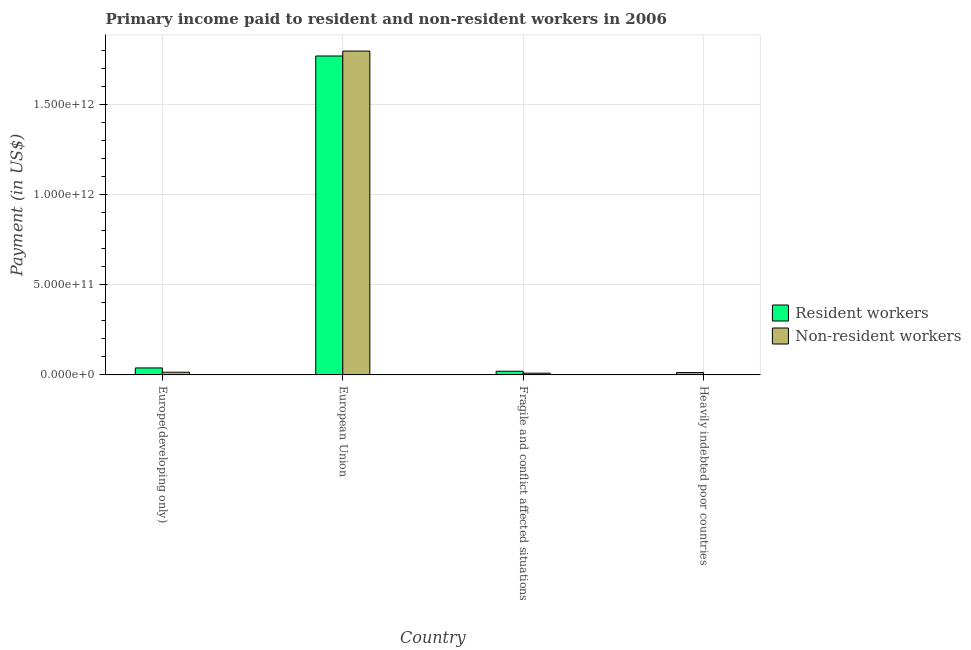How many different coloured bars are there?
Make the answer very short. 2. How many groups of bars are there?
Provide a short and direct response. 4. What is the label of the 4th group of bars from the left?
Give a very brief answer. Heavily indebted poor countries. What is the payment made to non-resident workers in Europe(developing only)?
Provide a short and direct response. 1.49e+1. Across all countries, what is the maximum payment made to resident workers?
Offer a very short reply. 1.77e+12. Across all countries, what is the minimum payment made to resident workers?
Ensure brevity in your answer.  1.30e+1. In which country was the payment made to resident workers maximum?
Offer a very short reply. European Union. In which country was the payment made to resident workers minimum?
Ensure brevity in your answer.  Heavily indebted poor countries. What is the total payment made to non-resident workers in the graph?
Your response must be concise. 1.83e+12. What is the difference between the payment made to resident workers in Europe(developing only) and that in Fragile and conflict affected situations?
Your answer should be compact. 1.84e+1. What is the difference between the payment made to resident workers in Europe(developing only) and the payment made to non-resident workers in Fragile and conflict affected situations?
Give a very brief answer. 2.91e+1. What is the average payment made to non-resident workers per country?
Keep it short and to the point. 4.56e+11. What is the difference between the payment made to resident workers and payment made to non-resident workers in Europe(developing only)?
Provide a short and direct response. 2.39e+1. In how many countries, is the payment made to non-resident workers greater than 1400000000000 US$?
Keep it short and to the point. 1. What is the ratio of the payment made to non-resident workers in Europe(developing only) to that in Heavily indebted poor countries?
Your response must be concise. 7.89. Is the payment made to resident workers in Europe(developing only) less than that in European Union?
Offer a very short reply. Yes. Is the difference between the payment made to resident workers in European Union and Fragile and conflict affected situations greater than the difference between the payment made to non-resident workers in European Union and Fragile and conflict affected situations?
Provide a short and direct response. No. What is the difference between the highest and the second highest payment made to non-resident workers?
Your answer should be compact. 1.78e+12. What is the difference between the highest and the lowest payment made to resident workers?
Your answer should be very brief. 1.76e+12. In how many countries, is the payment made to non-resident workers greater than the average payment made to non-resident workers taken over all countries?
Your answer should be very brief. 1. Is the sum of the payment made to resident workers in European Union and Fragile and conflict affected situations greater than the maximum payment made to non-resident workers across all countries?
Give a very brief answer. No. What does the 2nd bar from the left in Heavily indebted poor countries represents?
Make the answer very short. Non-resident workers. What does the 2nd bar from the right in European Union represents?
Your response must be concise. Resident workers. How many bars are there?
Make the answer very short. 8. How many countries are there in the graph?
Keep it short and to the point. 4. What is the difference between two consecutive major ticks on the Y-axis?
Provide a short and direct response. 5.00e+11. Does the graph contain any zero values?
Give a very brief answer. No. Does the graph contain grids?
Provide a short and direct response. Yes. How are the legend labels stacked?
Make the answer very short. Vertical. What is the title of the graph?
Ensure brevity in your answer.  Primary income paid to resident and non-resident workers in 2006. Does "Time to import" appear as one of the legend labels in the graph?
Your answer should be very brief. No. What is the label or title of the Y-axis?
Offer a very short reply. Payment (in US$). What is the Payment (in US$) of Resident workers in Europe(developing only)?
Your answer should be very brief. 3.88e+1. What is the Payment (in US$) in Non-resident workers in Europe(developing only)?
Keep it short and to the point. 1.49e+1. What is the Payment (in US$) of Resident workers in European Union?
Offer a very short reply. 1.77e+12. What is the Payment (in US$) of Non-resident workers in European Union?
Your answer should be very brief. 1.80e+12. What is the Payment (in US$) of Resident workers in Fragile and conflict affected situations?
Ensure brevity in your answer.  2.04e+1. What is the Payment (in US$) of Non-resident workers in Fragile and conflict affected situations?
Offer a terse response. 9.65e+09. What is the Payment (in US$) in Resident workers in Heavily indebted poor countries?
Keep it short and to the point. 1.30e+1. What is the Payment (in US$) of Non-resident workers in Heavily indebted poor countries?
Ensure brevity in your answer.  1.89e+09. Across all countries, what is the maximum Payment (in US$) of Resident workers?
Offer a very short reply. 1.77e+12. Across all countries, what is the maximum Payment (in US$) of Non-resident workers?
Make the answer very short. 1.80e+12. Across all countries, what is the minimum Payment (in US$) in Resident workers?
Offer a very short reply. 1.30e+1. Across all countries, what is the minimum Payment (in US$) in Non-resident workers?
Your answer should be compact. 1.89e+09. What is the total Payment (in US$) in Resident workers in the graph?
Offer a terse response. 1.84e+12. What is the total Payment (in US$) of Non-resident workers in the graph?
Provide a short and direct response. 1.83e+12. What is the difference between the Payment (in US$) in Resident workers in Europe(developing only) and that in European Union?
Ensure brevity in your answer.  -1.73e+12. What is the difference between the Payment (in US$) in Non-resident workers in Europe(developing only) and that in European Union?
Your response must be concise. -1.78e+12. What is the difference between the Payment (in US$) of Resident workers in Europe(developing only) and that in Fragile and conflict affected situations?
Make the answer very short. 1.84e+1. What is the difference between the Payment (in US$) of Non-resident workers in Europe(developing only) and that in Fragile and conflict affected situations?
Provide a succinct answer. 5.25e+09. What is the difference between the Payment (in US$) in Resident workers in Europe(developing only) and that in Heavily indebted poor countries?
Your response must be concise. 2.58e+1. What is the difference between the Payment (in US$) in Non-resident workers in Europe(developing only) and that in Heavily indebted poor countries?
Offer a very short reply. 1.30e+1. What is the difference between the Payment (in US$) in Resident workers in European Union and that in Fragile and conflict affected situations?
Give a very brief answer. 1.75e+12. What is the difference between the Payment (in US$) in Non-resident workers in European Union and that in Fragile and conflict affected situations?
Ensure brevity in your answer.  1.79e+12. What is the difference between the Payment (in US$) of Resident workers in European Union and that in Heavily indebted poor countries?
Your answer should be compact. 1.76e+12. What is the difference between the Payment (in US$) of Non-resident workers in European Union and that in Heavily indebted poor countries?
Provide a short and direct response. 1.80e+12. What is the difference between the Payment (in US$) in Resident workers in Fragile and conflict affected situations and that in Heavily indebted poor countries?
Give a very brief answer. 7.42e+09. What is the difference between the Payment (in US$) of Non-resident workers in Fragile and conflict affected situations and that in Heavily indebted poor countries?
Provide a short and direct response. 7.76e+09. What is the difference between the Payment (in US$) in Resident workers in Europe(developing only) and the Payment (in US$) in Non-resident workers in European Union?
Your response must be concise. -1.76e+12. What is the difference between the Payment (in US$) in Resident workers in Europe(developing only) and the Payment (in US$) in Non-resident workers in Fragile and conflict affected situations?
Offer a very short reply. 2.91e+1. What is the difference between the Payment (in US$) in Resident workers in Europe(developing only) and the Payment (in US$) in Non-resident workers in Heavily indebted poor countries?
Offer a terse response. 3.69e+1. What is the difference between the Payment (in US$) of Resident workers in European Union and the Payment (in US$) of Non-resident workers in Fragile and conflict affected situations?
Ensure brevity in your answer.  1.76e+12. What is the difference between the Payment (in US$) of Resident workers in European Union and the Payment (in US$) of Non-resident workers in Heavily indebted poor countries?
Your answer should be very brief. 1.77e+12. What is the difference between the Payment (in US$) in Resident workers in Fragile and conflict affected situations and the Payment (in US$) in Non-resident workers in Heavily indebted poor countries?
Provide a succinct answer. 1.85e+1. What is the average Payment (in US$) in Resident workers per country?
Ensure brevity in your answer.  4.61e+11. What is the average Payment (in US$) in Non-resident workers per country?
Provide a succinct answer. 4.56e+11. What is the difference between the Payment (in US$) in Resident workers and Payment (in US$) in Non-resident workers in Europe(developing only)?
Offer a very short reply. 2.39e+1. What is the difference between the Payment (in US$) of Resident workers and Payment (in US$) of Non-resident workers in European Union?
Your answer should be compact. -2.73e+1. What is the difference between the Payment (in US$) in Resident workers and Payment (in US$) in Non-resident workers in Fragile and conflict affected situations?
Offer a very short reply. 1.08e+1. What is the difference between the Payment (in US$) of Resident workers and Payment (in US$) of Non-resident workers in Heavily indebted poor countries?
Provide a short and direct response. 1.11e+1. What is the ratio of the Payment (in US$) in Resident workers in Europe(developing only) to that in European Union?
Keep it short and to the point. 0.02. What is the ratio of the Payment (in US$) in Non-resident workers in Europe(developing only) to that in European Union?
Your response must be concise. 0.01. What is the ratio of the Payment (in US$) of Resident workers in Europe(developing only) to that in Fragile and conflict affected situations?
Your answer should be compact. 1.9. What is the ratio of the Payment (in US$) of Non-resident workers in Europe(developing only) to that in Fragile and conflict affected situations?
Ensure brevity in your answer.  1.54. What is the ratio of the Payment (in US$) in Resident workers in Europe(developing only) to that in Heavily indebted poor countries?
Your response must be concise. 2.98. What is the ratio of the Payment (in US$) of Non-resident workers in Europe(developing only) to that in Heavily indebted poor countries?
Ensure brevity in your answer.  7.89. What is the ratio of the Payment (in US$) of Resident workers in European Union to that in Fragile and conflict affected situations?
Provide a short and direct response. 86.83. What is the ratio of the Payment (in US$) in Non-resident workers in European Union to that in Fragile and conflict affected situations?
Keep it short and to the point. 186.43. What is the ratio of the Payment (in US$) in Resident workers in European Union to that in Heavily indebted poor countries?
Your answer should be compact. 136.4. What is the ratio of the Payment (in US$) of Non-resident workers in European Union to that in Heavily indebted poor countries?
Your response must be concise. 952.92. What is the ratio of the Payment (in US$) in Resident workers in Fragile and conflict affected situations to that in Heavily indebted poor countries?
Provide a short and direct response. 1.57. What is the ratio of the Payment (in US$) in Non-resident workers in Fragile and conflict affected situations to that in Heavily indebted poor countries?
Keep it short and to the point. 5.11. What is the difference between the highest and the second highest Payment (in US$) of Resident workers?
Your response must be concise. 1.73e+12. What is the difference between the highest and the second highest Payment (in US$) of Non-resident workers?
Your answer should be very brief. 1.78e+12. What is the difference between the highest and the lowest Payment (in US$) in Resident workers?
Provide a succinct answer. 1.76e+12. What is the difference between the highest and the lowest Payment (in US$) of Non-resident workers?
Make the answer very short. 1.80e+12. 